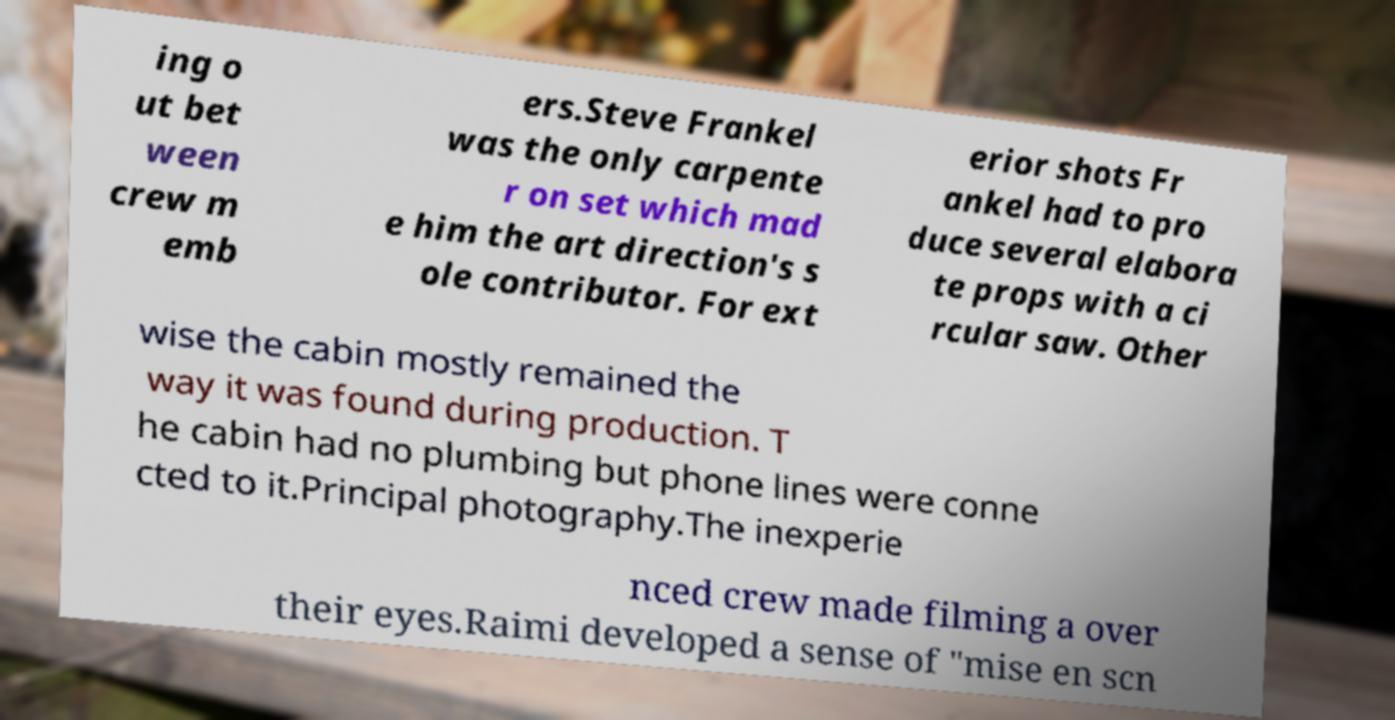Can you read and provide the text displayed in the image?This photo seems to have some interesting text. Can you extract and type it out for me? ing o ut bet ween crew m emb ers.Steve Frankel was the only carpente r on set which mad e him the art direction's s ole contributor. For ext erior shots Fr ankel had to pro duce several elabora te props with a ci rcular saw. Other wise the cabin mostly remained the way it was found during production. T he cabin had no plumbing but phone lines were conne cted to it.Principal photography.The inexperie nced crew made filming a over their eyes.Raimi developed a sense of "mise en scn 